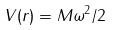<formula> <loc_0><loc_0><loc_500><loc_500>V ( r ) = M \omega ^ { 2 } / 2</formula> 